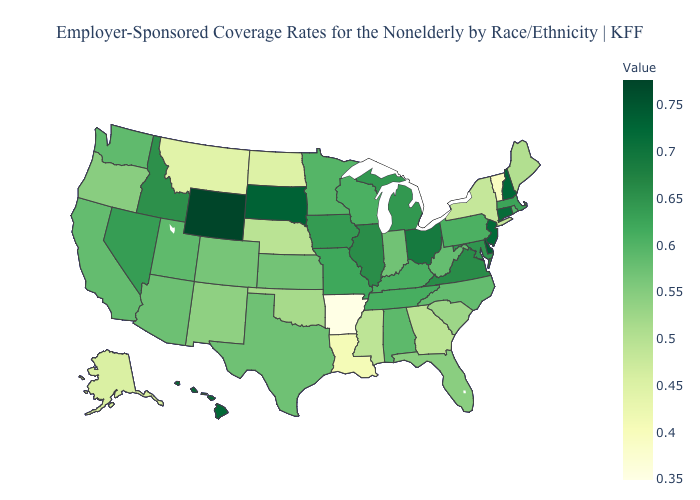Which states have the lowest value in the USA?
Give a very brief answer. Arkansas. Does North Dakota have a higher value than Vermont?
Give a very brief answer. Yes. Among the states that border Rhode Island , does Connecticut have the lowest value?
Concise answer only. No. Does Delaware have the highest value in the South?
Short answer required. Yes. Among the states that border Wyoming , which have the lowest value?
Short answer required. Montana. Which states have the lowest value in the USA?
Give a very brief answer. Arkansas. Does New Mexico have the highest value in the USA?
Concise answer only. No. Among the states that border Delaware , which have the highest value?
Be succinct. New Jersey. Does Montana have the lowest value in the West?
Keep it brief. Yes. Among the states that border Missouri , which have the lowest value?
Short answer required. Arkansas. 